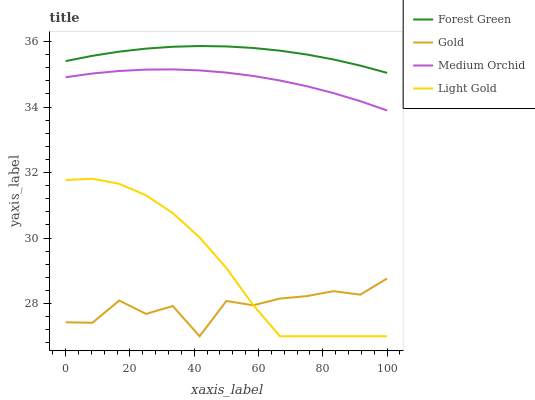Does Gold have the minimum area under the curve?
Answer yes or no. Yes. Does Forest Green have the maximum area under the curve?
Answer yes or no. Yes. Does Medium Orchid have the minimum area under the curve?
Answer yes or no. No. Does Medium Orchid have the maximum area under the curve?
Answer yes or no. No. Is Forest Green the smoothest?
Answer yes or no. Yes. Is Gold the roughest?
Answer yes or no. Yes. Is Medium Orchid the smoothest?
Answer yes or no. No. Is Medium Orchid the roughest?
Answer yes or no. No. Does Light Gold have the lowest value?
Answer yes or no. Yes. Does Medium Orchid have the lowest value?
Answer yes or no. No. Does Forest Green have the highest value?
Answer yes or no. Yes. Does Medium Orchid have the highest value?
Answer yes or no. No. Is Gold less than Medium Orchid?
Answer yes or no. Yes. Is Medium Orchid greater than Light Gold?
Answer yes or no. Yes. Does Light Gold intersect Gold?
Answer yes or no. Yes. Is Light Gold less than Gold?
Answer yes or no. No. Is Light Gold greater than Gold?
Answer yes or no. No. Does Gold intersect Medium Orchid?
Answer yes or no. No. 